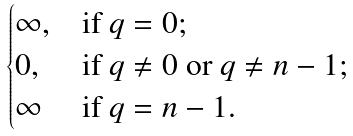<formula> <loc_0><loc_0><loc_500><loc_500>\begin{cases} \infty , & \text {if $q=0$;} \\ 0 , & \text {if $q\not=0$ or $q\not=n-1$;} \\ \infty & \text {if $q=n-1$.} \end{cases}</formula> 